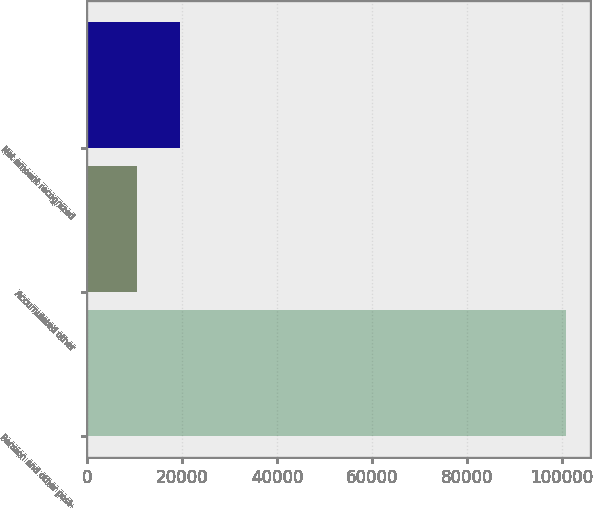Convert chart. <chart><loc_0><loc_0><loc_500><loc_500><bar_chart><fcel>Pension and other post-<fcel>Accumulated other<fcel>Net amount recognized<nl><fcel>100863<fcel>10519<fcel>19553.4<nl></chart> 